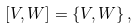<formula> <loc_0><loc_0><loc_500><loc_500>[ V , W ] = \{ V , W \} \, ,</formula> 